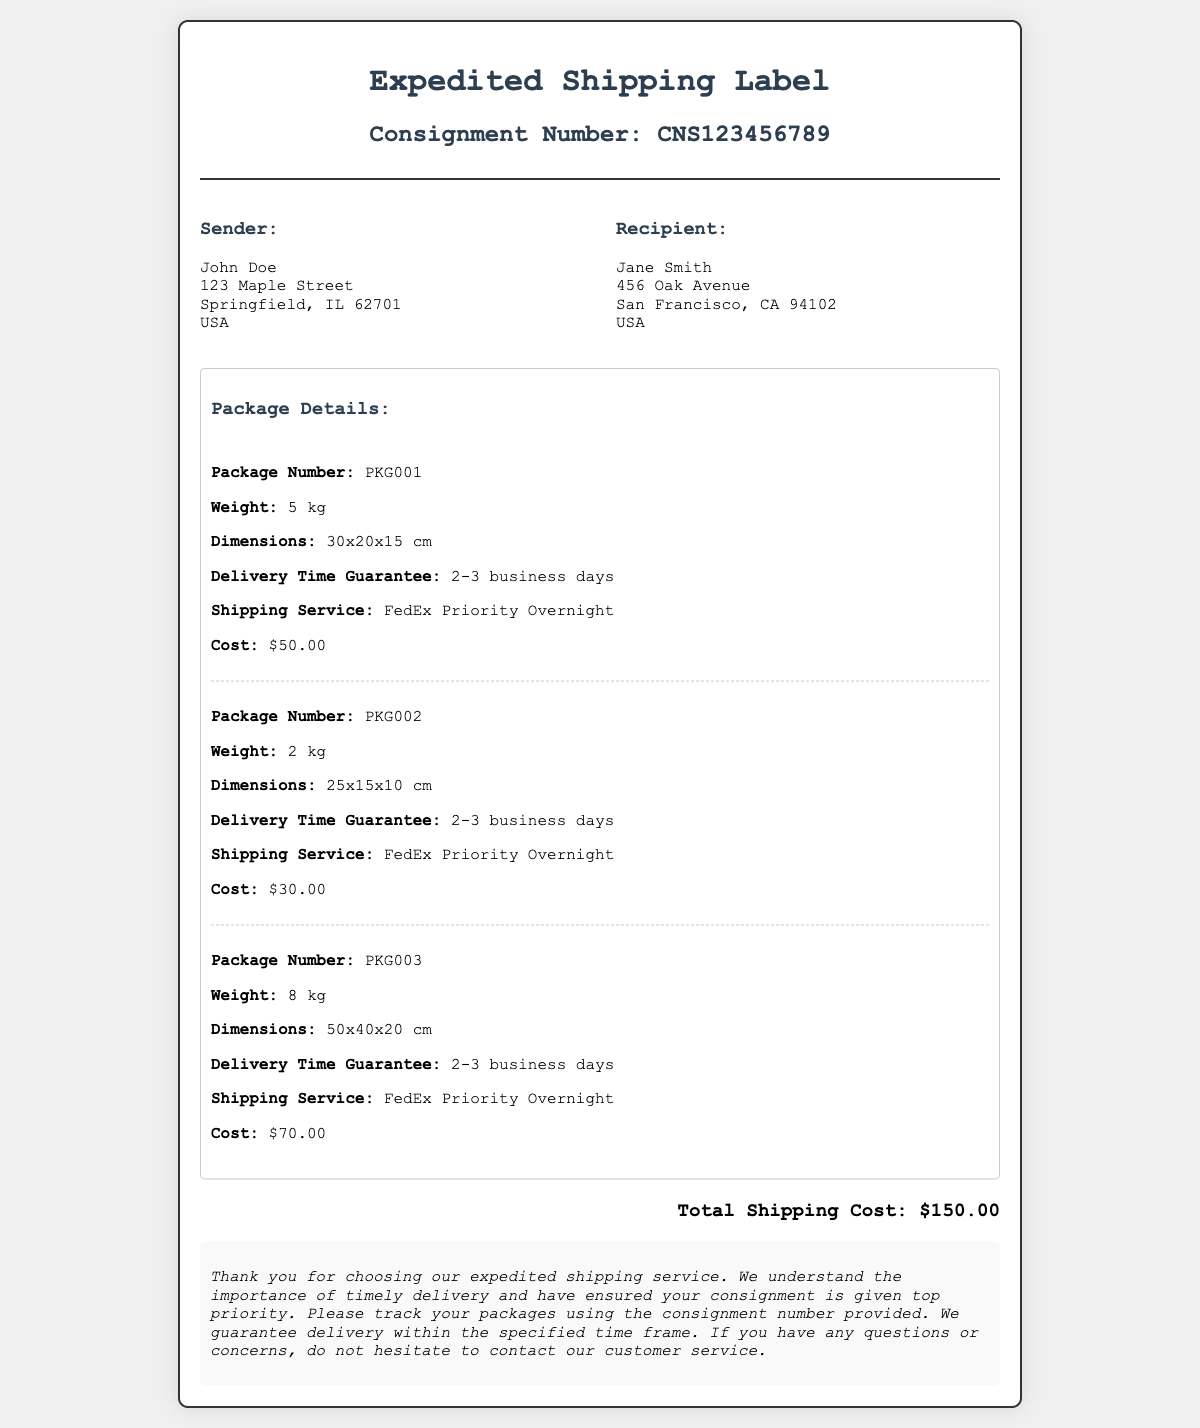What is the consignment number? The consignment number is specified in the header of the document.
Answer: CNS123456789 Who is the sender? The sender's name is provided in the document.
Answer: John Doe What is the weight of package number PKG002? The weight of this specific package is listed in the package details.
Answer: 2 kg What are the dimensions of package number PKG003? The dimensions are given in the details for this package.
Answer: 50x40x20 cm What is the total shipping cost? The total shipping cost is found at the bottom of the document.
Answer: $150.00 What delivery time guarantee is provided? The delivery time guarantee applies to all packages mentioned in the document.
Answer: 2-3 business days Which shipping service is used? The shipping service is identified in each package's details.
Answer: FedEx Priority Overnight How many packages are listed? The total number of packages can be counted from the document.
Answer: 3 packages What is the weight of the heaviest package? The weight of the heaviest package can be inferred from the package details.
Answer: 8 kg 